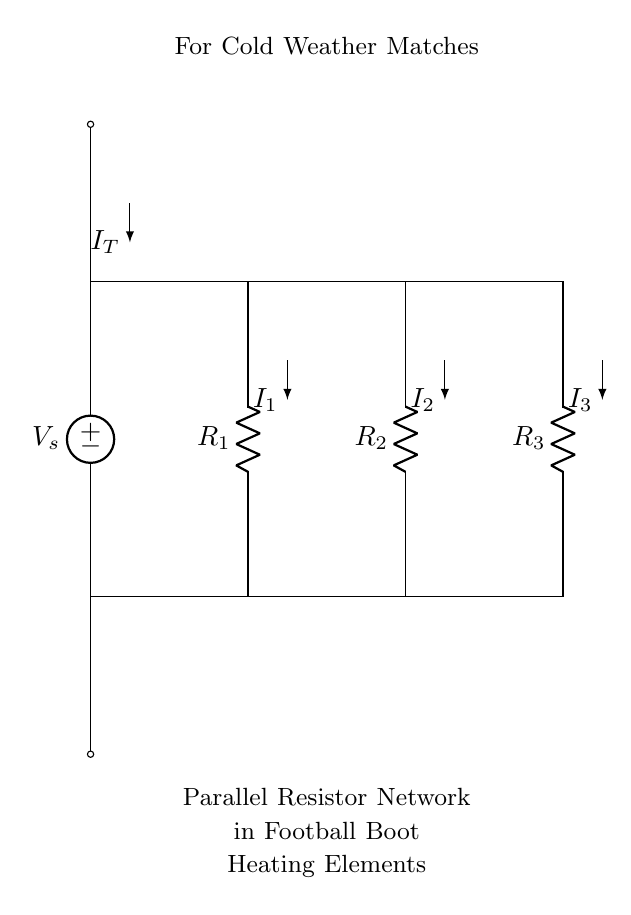What is the source voltage in this circuit? The source voltage is denoted as \( V_s \), which is the voltage provided by the voltage source at the top of the circuit diagram.
Answer: V_s How many resistors are in parallel in this network? There are three resistors represented as \( R_1 \), \( R_2 \), and \( R_3 \) in the parallel configuration in the circuit diagram.
Answer: Three What is the total current entering the circuit? The total current entering the circuit is represented as \( I_T \), which is the sum of the individual currents \( I_1 \), \( I_2 \), and \( I_3 \) flowing through each resistor.
Answer: I_T How does the current divide among the resistors? The current divides according to the resistances of each branch, with lower resistance receiving higher current based on the current divider rule, specifically \( I_x = I_T \cdot \frac{R_{total}}{R_x} \).
Answer: Depends on resistance Which resistor would cause the highest current to flow through it? The lowest resistance value among the resistors \( R_1 \), \( R_2 \), and \( R_3 \) would result in the highest current flow according to the current divider principle.
Answer: Lowest resistance If \( R_1 \) is 4 ohms, \( R_2 \) is 6 ohms, and \( R_3 \) is 12 ohms, what is the equivalent resistance of the parallel circuit? The equivalent resistance \( R_{eq} \) of a parallel circuit can be calculated using the formula \( \frac{1}{R_{eq}} = \frac{1}{R_1} + \frac{1}{R_2} + \frac{1}{R_3} \) which leads to \( R_{eq} = 2 \) ohms.
Answer: 2 ohms 